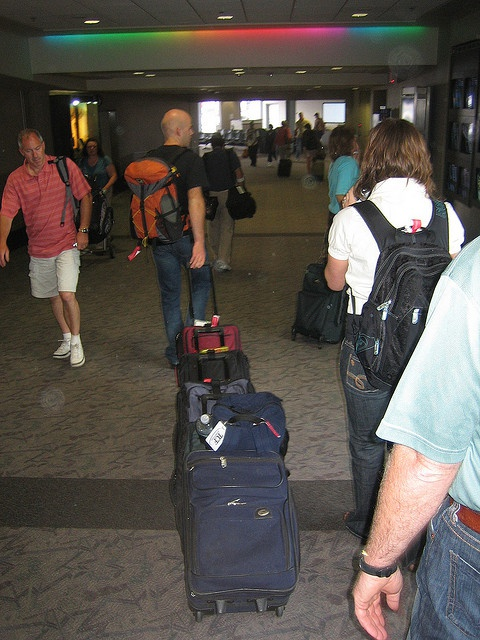Describe the objects in this image and their specific colors. I can see people in black, white, gray, lightpink, and lightblue tones, people in black, white, and gray tones, suitcase in black and gray tones, people in black, brown, and maroon tones, and backpack in black, gray, and purple tones in this image. 